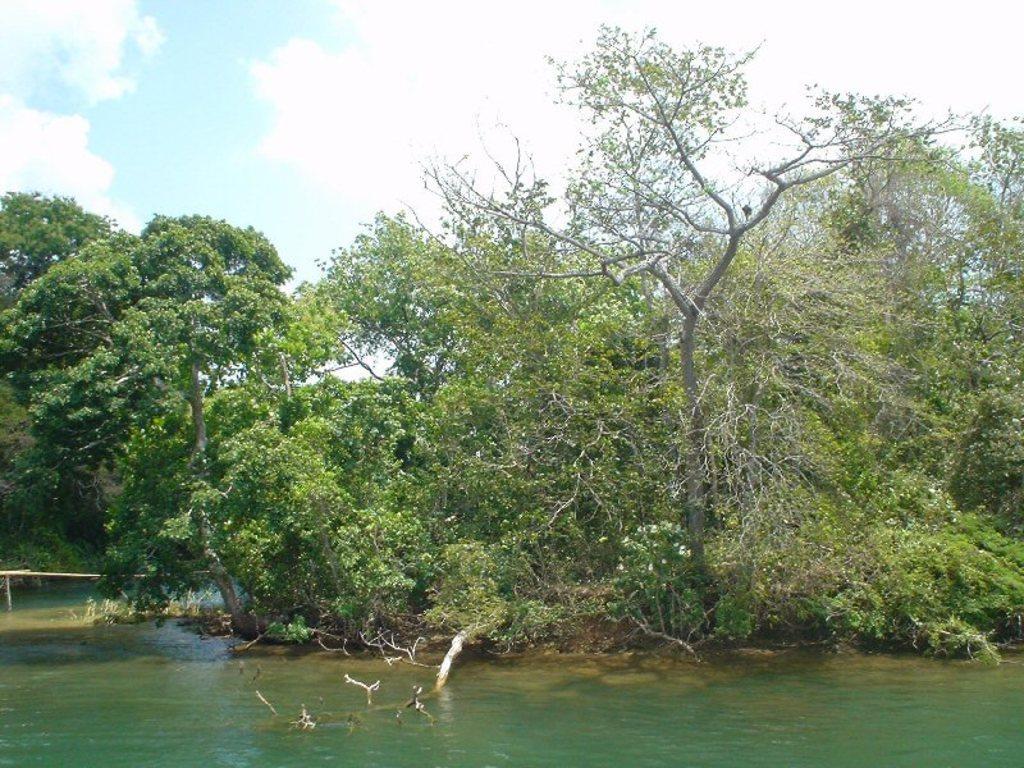Describe this image in one or two sentences. In this image I can see the water and few trees which are green in color. In the background I can see the sky. 